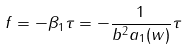<formula> <loc_0><loc_0><loc_500><loc_500>f = - \beta _ { 1 } \tau = - \frac { 1 } { b ^ { 2 } a _ { 1 } ( w ) } \tau</formula> 